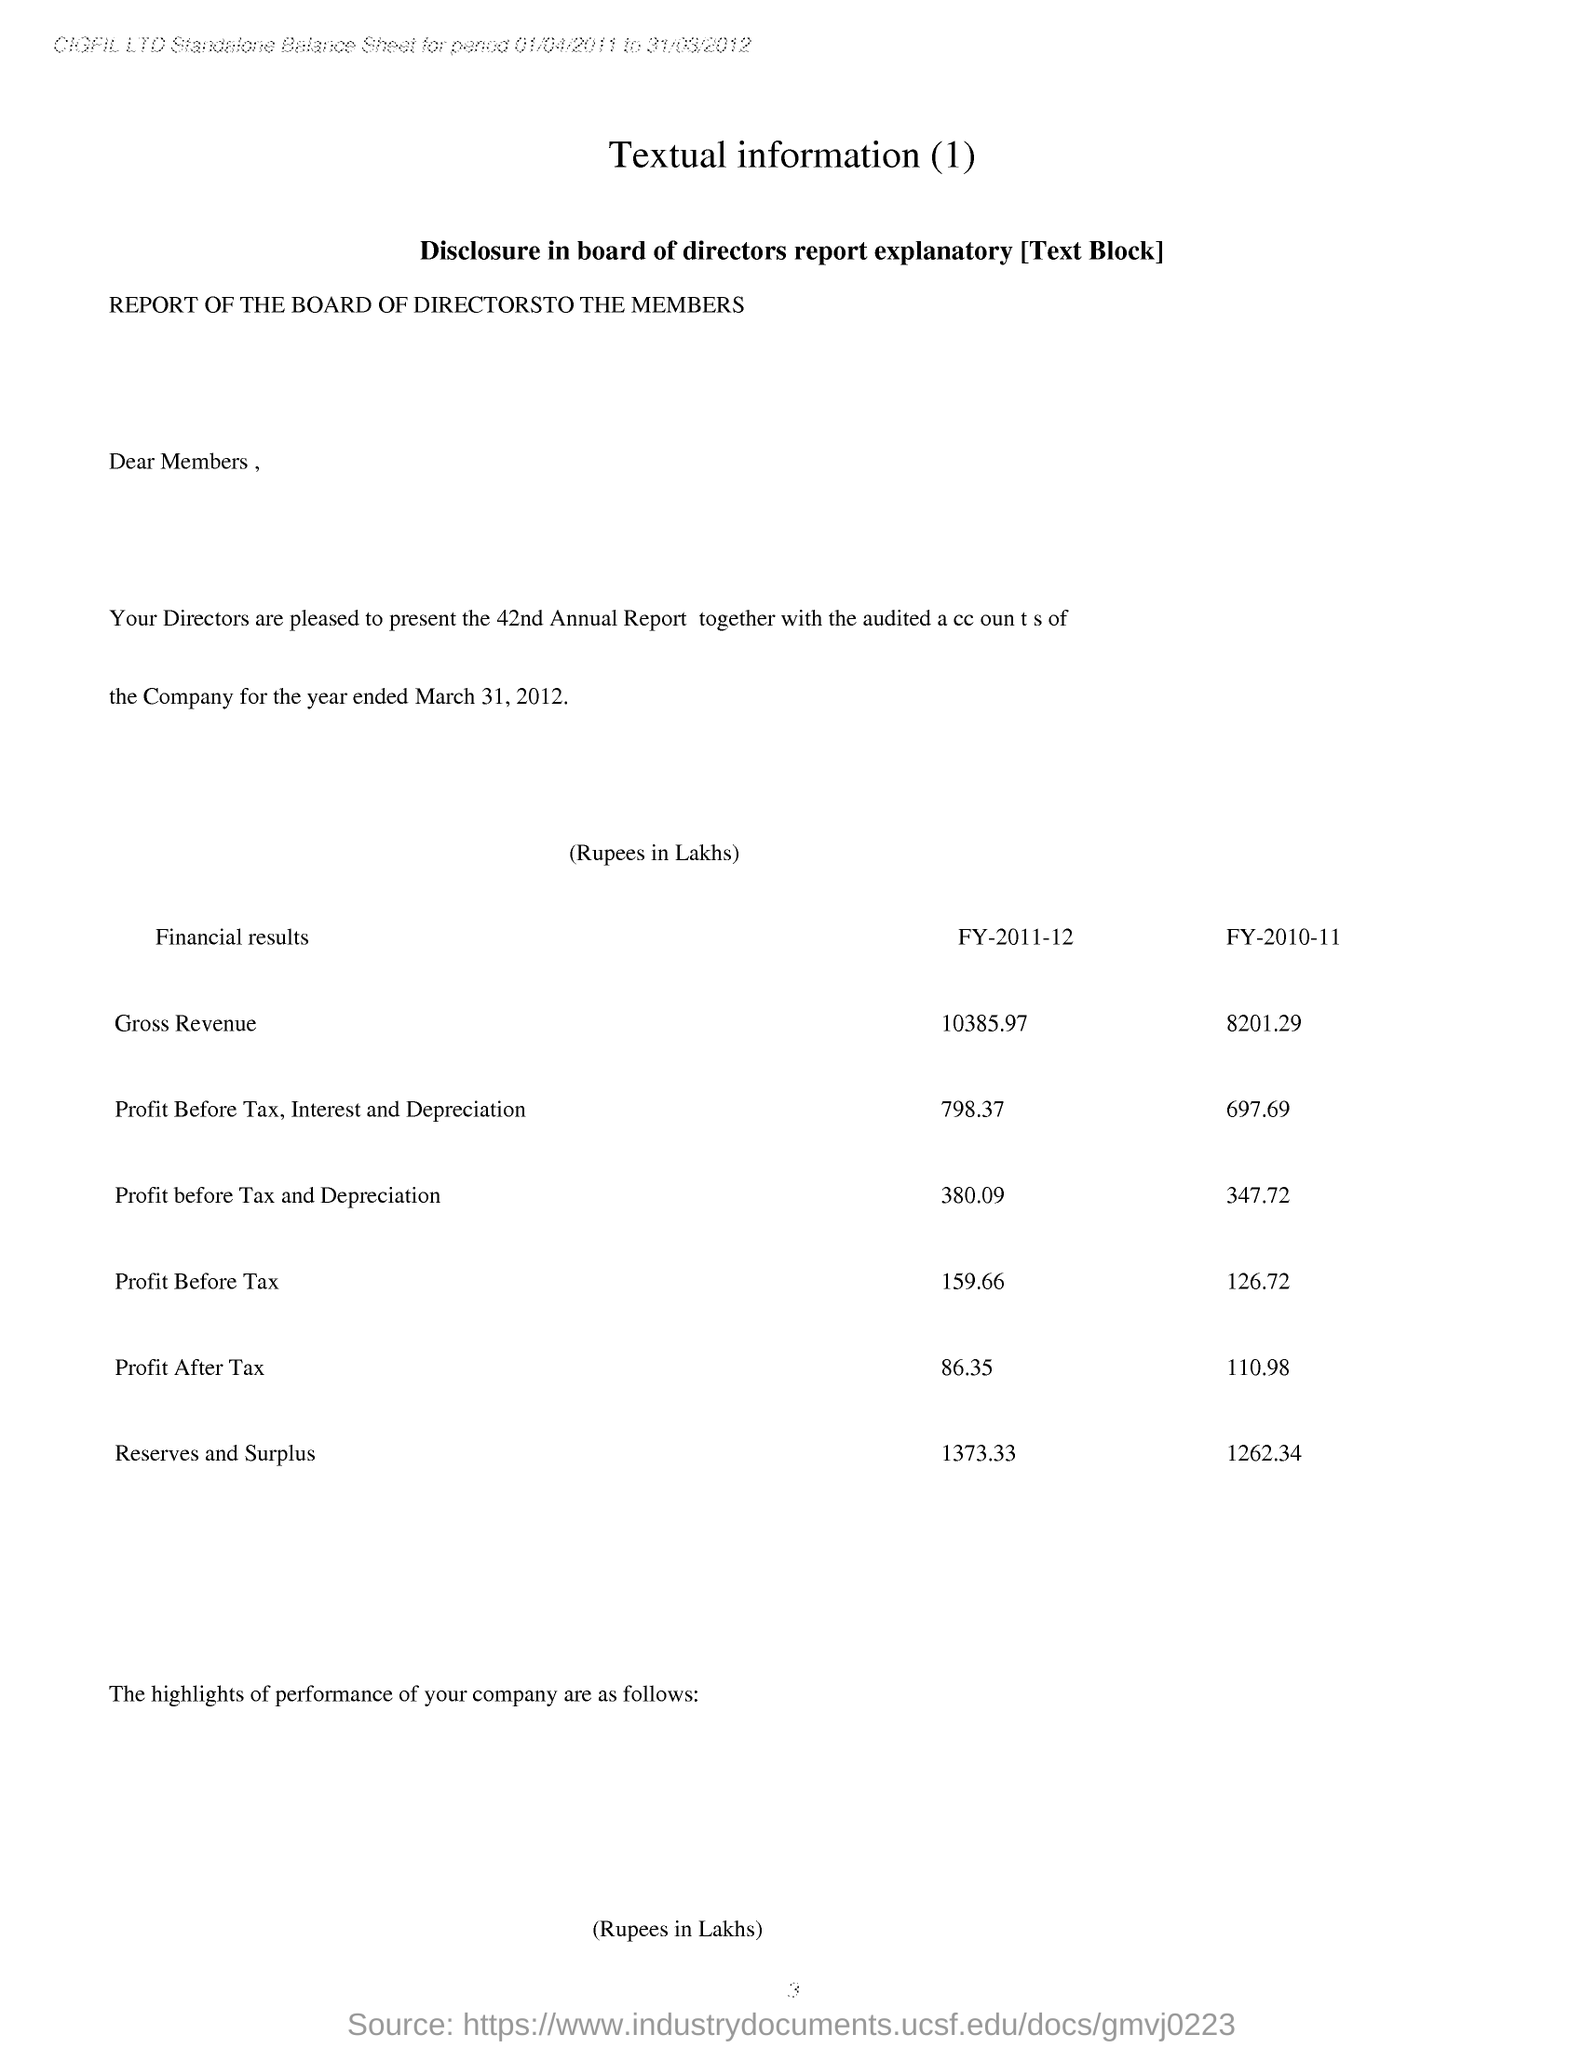What is the Heading of this page
Provide a succinct answer. Textual information(1). What is the profit before tax of company given for fy-2011-12
Offer a terse response. 159.66. What is Profit After Tax of company given for fy-2011-12
Offer a very short reply. 86.35. 